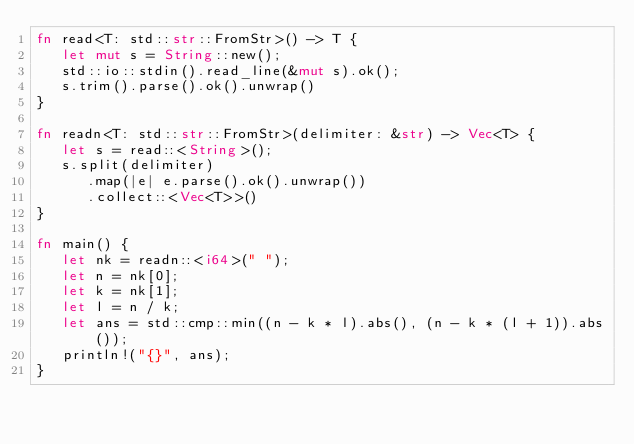<code> <loc_0><loc_0><loc_500><loc_500><_Rust_>fn read<T: std::str::FromStr>() -> T {
   let mut s = String::new();
   std::io::stdin().read_line(&mut s).ok();
   s.trim().parse().ok().unwrap()
}

fn readn<T: std::str::FromStr>(delimiter: &str) -> Vec<T> {
   let s = read::<String>();
   s.split(delimiter)
      .map(|e| e.parse().ok().unwrap())
      .collect::<Vec<T>>()
}

fn main() {
   let nk = readn::<i64>(" ");
   let n = nk[0];
   let k = nk[1];
   let l = n / k;
   let ans = std::cmp::min((n - k * l).abs(), (n - k * (l + 1)).abs());
   println!("{}", ans);
}
</code> 